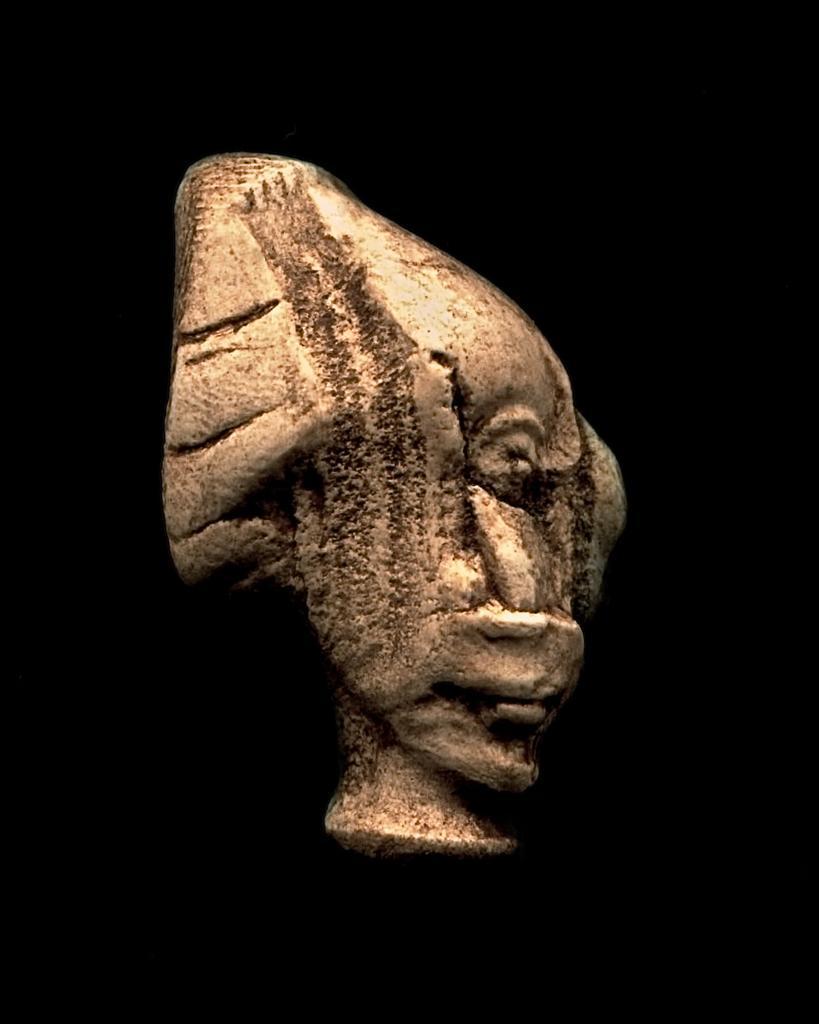In one or two sentences, can you explain what this image depicts? This image consists of a sculpture. The background is black in color. 